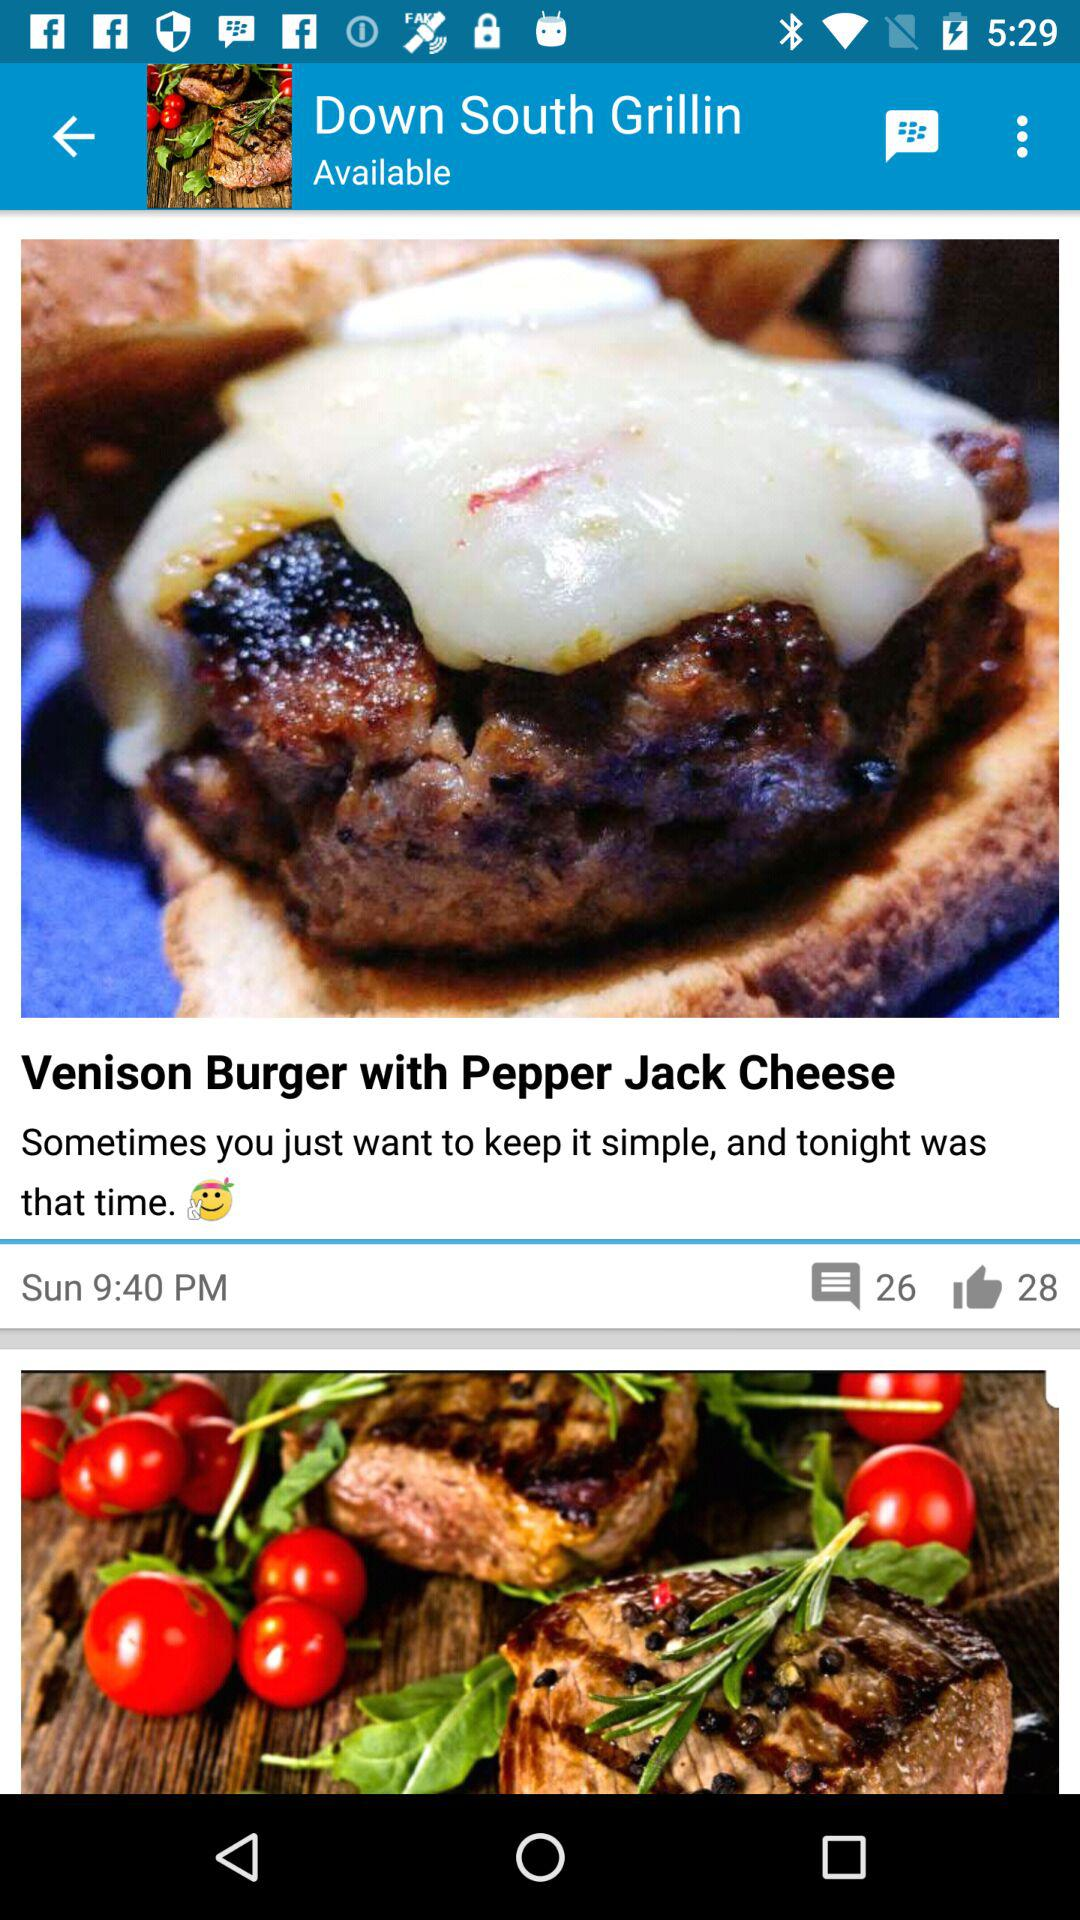How many likes are there of "Venison Burger with Pepper Jack Cheese"? There are 28 likes. 